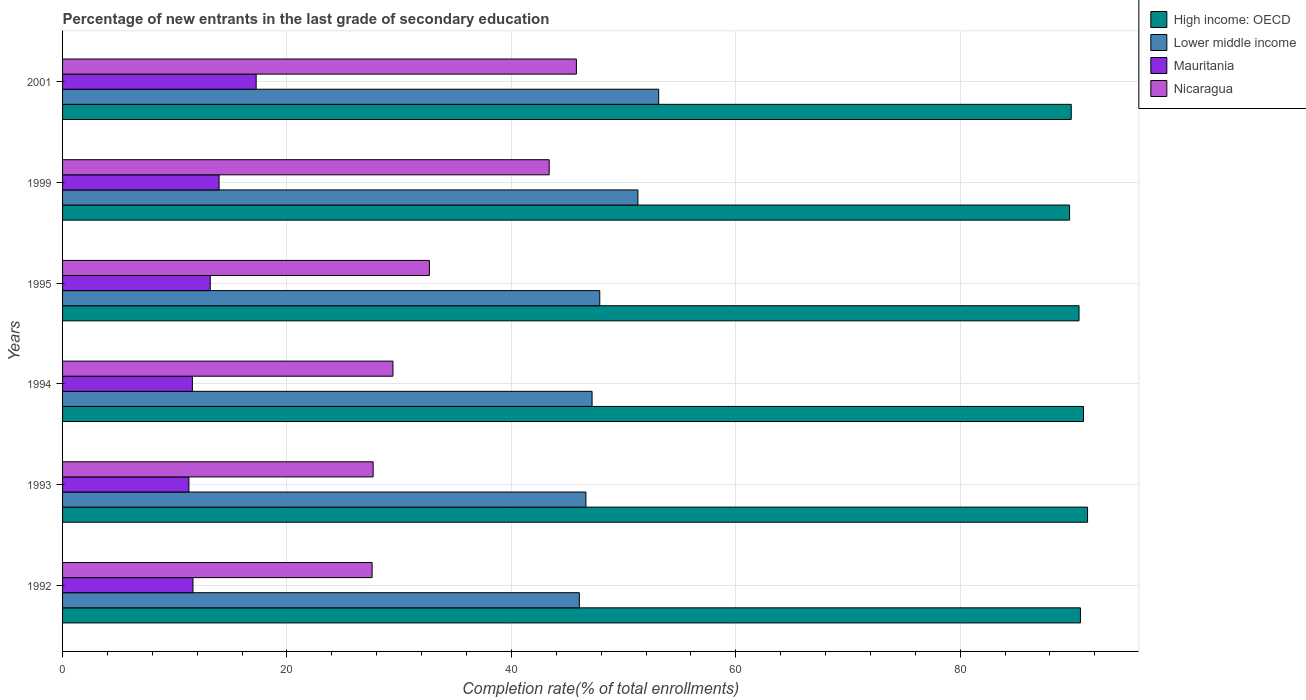How many different coloured bars are there?
Make the answer very short. 4. Are the number of bars per tick equal to the number of legend labels?
Make the answer very short. Yes. What is the label of the 2nd group of bars from the top?
Ensure brevity in your answer.  1999. In how many cases, is the number of bars for a given year not equal to the number of legend labels?
Provide a short and direct response. 0. What is the percentage of new entrants in Lower middle income in 1994?
Make the answer very short. 47.19. Across all years, what is the maximum percentage of new entrants in Mauritania?
Keep it short and to the point. 17.25. Across all years, what is the minimum percentage of new entrants in Nicaragua?
Ensure brevity in your answer.  27.59. In which year was the percentage of new entrants in Mauritania maximum?
Keep it short and to the point. 2001. What is the total percentage of new entrants in Nicaragua in the graph?
Give a very brief answer. 206.58. What is the difference between the percentage of new entrants in Mauritania in 1993 and that in 2001?
Offer a terse response. -5.99. What is the difference between the percentage of new entrants in Mauritania in 1993 and the percentage of new entrants in Lower middle income in 1995?
Your response must be concise. -36.62. What is the average percentage of new entrants in Lower middle income per year?
Keep it short and to the point. 48.7. In the year 2001, what is the difference between the percentage of new entrants in Lower middle income and percentage of new entrants in High income: OECD?
Provide a short and direct response. -36.77. In how many years, is the percentage of new entrants in Mauritania greater than 44 %?
Your answer should be compact. 0. What is the ratio of the percentage of new entrants in Nicaragua in 1992 to that in 2001?
Provide a succinct answer. 0.6. Is the percentage of new entrants in High income: OECD in 1992 less than that in 1995?
Your answer should be compact. No. Is the difference between the percentage of new entrants in Lower middle income in 1992 and 1995 greater than the difference between the percentage of new entrants in High income: OECD in 1992 and 1995?
Your response must be concise. No. What is the difference between the highest and the second highest percentage of new entrants in Nicaragua?
Provide a succinct answer. 2.42. What is the difference between the highest and the lowest percentage of new entrants in Nicaragua?
Offer a very short reply. 18.21. Is the sum of the percentage of new entrants in High income: OECD in 1995 and 2001 greater than the maximum percentage of new entrants in Lower middle income across all years?
Give a very brief answer. Yes. What does the 4th bar from the top in 1993 represents?
Your answer should be compact. High income: OECD. What does the 4th bar from the bottom in 1993 represents?
Your answer should be very brief. Nicaragua. Is it the case that in every year, the sum of the percentage of new entrants in High income: OECD and percentage of new entrants in Lower middle income is greater than the percentage of new entrants in Nicaragua?
Provide a short and direct response. Yes. What is the difference between two consecutive major ticks on the X-axis?
Offer a terse response. 20. Does the graph contain any zero values?
Give a very brief answer. No. How are the legend labels stacked?
Offer a very short reply. Vertical. What is the title of the graph?
Make the answer very short. Percentage of new entrants in the last grade of secondary education. Does "Macedonia" appear as one of the legend labels in the graph?
Offer a very short reply. No. What is the label or title of the X-axis?
Your response must be concise. Completion rate(% of total enrollments). What is the Completion rate(% of total enrollments) of High income: OECD in 1992?
Offer a very short reply. 90.72. What is the Completion rate(% of total enrollments) of Lower middle income in 1992?
Give a very brief answer. 46.06. What is the Completion rate(% of total enrollments) in Mauritania in 1992?
Give a very brief answer. 11.62. What is the Completion rate(% of total enrollments) in Nicaragua in 1992?
Ensure brevity in your answer.  27.59. What is the Completion rate(% of total enrollments) of High income: OECD in 1993?
Ensure brevity in your answer.  91.36. What is the Completion rate(% of total enrollments) of Lower middle income in 1993?
Offer a very short reply. 46.64. What is the Completion rate(% of total enrollments) of Mauritania in 1993?
Ensure brevity in your answer.  11.26. What is the Completion rate(% of total enrollments) in Nicaragua in 1993?
Your answer should be very brief. 27.68. What is the Completion rate(% of total enrollments) of High income: OECD in 1994?
Your response must be concise. 90.99. What is the Completion rate(% of total enrollments) in Lower middle income in 1994?
Provide a succinct answer. 47.19. What is the Completion rate(% of total enrollments) in Mauritania in 1994?
Offer a terse response. 11.57. What is the Completion rate(% of total enrollments) of Nicaragua in 1994?
Offer a terse response. 29.45. What is the Completion rate(% of total enrollments) of High income: OECD in 1995?
Your answer should be compact. 90.6. What is the Completion rate(% of total enrollments) of Lower middle income in 1995?
Your answer should be very brief. 47.88. What is the Completion rate(% of total enrollments) of Mauritania in 1995?
Give a very brief answer. 13.16. What is the Completion rate(% of total enrollments) of Nicaragua in 1995?
Keep it short and to the point. 32.7. What is the Completion rate(% of total enrollments) in High income: OECD in 1999?
Provide a short and direct response. 89.75. What is the Completion rate(% of total enrollments) of Lower middle income in 1999?
Provide a succinct answer. 51.28. What is the Completion rate(% of total enrollments) of Mauritania in 1999?
Your response must be concise. 13.95. What is the Completion rate(% of total enrollments) of Nicaragua in 1999?
Your answer should be very brief. 43.37. What is the Completion rate(% of total enrollments) of High income: OECD in 2001?
Make the answer very short. 89.9. What is the Completion rate(% of total enrollments) of Lower middle income in 2001?
Provide a short and direct response. 53.13. What is the Completion rate(% of total enrollments) in Mauritania in 2001?
Offer a very short reply. 17.25. What is the Completion rate(% of total enrollments) of Nicaragua in 2001?
Your answer should be compact. 45.8. Across all years, what is the maximum Completion rate(% of total enrollments) of High income: OECD?
Provide a short and direct response. 91.36. Across all years, what is the maximum Completion rate(% of total enrollments) of Lower middle income?
Keep it short and to the point. 53.13. Across all years, what is the maximum Completion rate(% of total enrollments) of Mauritania?
Ensure brevity in your answer.  17.25. Across all years, what is the maximum Completion rate(% of total enrollments) in Nicaragua?
Keep it short and to the point. 45.8. Across all years, what is the minimum Completion rate(% of total enrollments) of High income: OECD?
Give a very brief answer. 89.75. Across all years, what is the minimum Completion rate(% of total enrollments) in Lower middle income?
Keep it short and to the point. 46.06. Across all years, what is the minimum Completion rate(% of total enrollments) in Mauritania?
Your response must be concise. 11.26. Across all years, what is the minimum Completion rate(% of total enrollments) of Nicaragua?
Make the answer very short. 27.59. What is the total Completion rate(% of total enrollments) in High income: OECD in the graph?
Make the answer very short. 543.32. What is the total Completion rate(% of total enrollments) in Lower middle income in the graph?
Give a very brief answer. 292.19. What is the total Completion rate(% of total enrollments) of Mauritania in the graph?
Ensure brevity in your answer.  78.82. What is the total Completion rate(% of total enrollments) of Nicaragua in the graph?
Offer a very short reply. 206.58. What is the difference between the Completion rate(% of total enrollments) in High income: OECD in 1992 and that in 1993?
Make the answer very short. -0.64. What is the difference between the Completion rate(% of total enrollments) of Lower middle income in 1992 and that in 1993?
Your answer should be very brief. -0.58. What is the difference between the Completion rate(% of total enrollments) of Mauritania in 1992 and that in 1993?
Provide a succinct answer. 0.36. What is the difference between the Completion rate(% of total enrollments) of Nicaragua in 1992 and that in 1993?
Give a very brief answer. -0.09. What is the difference between the Completion rate(% of total enrollments) of High income: OECD in 1992 and that in 1994?
Keep it short and to the point. -0.27. What is the difference between the Completion rate(% of total enrollments) in Lower middle income in 1992 and that in 1994?
Your response must be concise. -1.13. What is the difference between the Completion rate(% of total enrollments) of Mauritania in 1992 and that in 1994?
Your response must be concise. 0.05. What is the difference between the Completion rate(% of total enrollments) in Nicaragua in 1992 and that in 1994?
Keep it short and to the point. -1.86. What is the difference between the Completion rate(% of total enrollments) of High income: OECD in 1992 and that in 1995?
Give a very brief answer. 0.12. What is the difference between the Completion rate(% of total enrollments) in Lower middle income in 1992 and that in 1995?
Keep it short and to the point. -1.82. What is the difference between the Completion rate(% of total enrollments) in Mauritania in 1992 and that in 1995?
Provide a succinct answer. -1.54. What is the difference between the Completion rate(% of total enrollments) of Nicaragua in 1992 and that in 1995?
Make the answer very short. -5.11. What is the difference between the Completion rate(% of total enrollments) of High income: OECD in 1992 and that in 1999?
Ensure brevity in your answer.  0.97. What is the difference between the Completion rate(% of total enrollments) of Lower middle income in 1992 and that in 1999?
Provide a succinct answer. -5.22. What is the difference between the Completion rate(% of total enrollments) in Mauritania in 1992 and that in 1999?
Offer a terse response. -2.33. What is the difference between the Completion rate(% of total enrollments) in Nicaragua in 1992 and that in 1999?
Provide a short and direct response. -15.78. What is the difference between the Completion rate(% of total enrollments) in High income: OECD in 1992 and that in 2001?
Your answer should be compact. 0.82. What is the difference between the Completion rate(% of total enrollments) of Lower middle income in 1992 and that in 2001?
Provide a short and direct response. -7.07. What is the difference between the Completion rate(% of total enrollments) in Mauritania in 1992 and that in 2001?
Offer a terse response. -5.63. What is the difference between the Completion rate(% of total enrollments) of Nicaragua in 1992 and that in 2001?
Ensure brevity in your answer.  -18.21. What is the difference between the Completion rate(% of total enrollments) in High income: OECD in 1993 and that in 1994?
Your answer should be very brief. 0.37. What is the difference between the Completion rate(% of total enrollments) in Lower middle income in 1993 and that in 1994?
Provide a succinct answer. -0.55. What is the difference between the Completion rate(% of total enrollments) in Mauritania in 1993 and that in 1994?
Provide a short and direct response. -0.31. What is the difference between the Completion rate(% of total enrollments) of Nicaragua in 1993 and that in 1994?
Provide a succinct answer. -1.77. What is the difference between the Completion rate(% of total enrollments) in High income: OECD in 1993 and that in 1995?
Your answer should be compact. 0.76. What is the difference between the Completion rate(% of total enrollments) of Lower middle income in 1993 and that in 1995?
Your response must be concise. -1.24. What is the difference between the Completion rate(% of total enrollments) in Mauritania in 1993 and that in 1995?
Give a very brief answer. -1.9. What is the difference between the Completion rate(% of total enrollments) of Nicaragua in 1993 and that in 1995?
Provide a short and direct response. -5.01. What is the difference between the Completion rate(% of total enrollments) in High income: OECD in 1993 and that in 1999?
Offer a very short reply. 1.6. What is the difference between the Completion rate(% of total enrollments) in Lower middle income in 1993 and that in 1999?
Your response must be concise. -4.64. What is the difference between the Completion rate(% of total enrollments) of Mauritania in 1993 and that in 1999?
Your answer should be compact. -2.69. What is the difference between the Completion rate(% of total enrollments) of Nicaragua in 1993 and that in 1999?
Your answer should be compact. -15.69. What is the difference between the Completion rate(% of total enrollments) in High income: OECD in 1993 and that in 2001?
Your answer should be very brief. 1.45. What is the difference between the Completion rate(% of total enrollments) of Lower middle income in 1993 and that in 2001?
Your answer should be compact. -6.49. What is the difference between the Completion rate(% of total enrollments) in Mauritania in 1993 and that in 2001?
Offer a very short reply. -5.99. What is the difference between the Completion rate(% of total enrollments) in Nicaragua in 1993 and that in 2001?
Your response must be concise. -18.12. What is the difference between the Completion rate(% of total enrollments) of High income: OECD in 1994 and that in 1995?
Your answer should be very brief. 0.4. What is the difference between the Completion rate(% of total enrollments) of Lower middle income in 1994 and that in 1995?
Offer a very short reply. -0.69. What is the difference between the Completion rate(% of total enrollments) in Mauritania in 1994 and that in 1995?
Make the answer very short. -1.59. What is the difference between the Completion rate(% of total enrollments) in Nicaragua in 1994 and that in 1995?
Provide a short and direct response. -3.25. What is the difference between the Completion rate(% of total enrollments) in High income: OECD in 1994 and that in 1999?
Provide a short and direct response. 1.24. What is the difference between the Completion rate(% of total enrollments) of Lower middle income in 1994 and that in 1999?
Offer a very short reply. -4.09. What is the difference between the Completion rate(% of total enrollments) in Mauritania in 1994 and that in 1999?
Ensure brevity in your answer.  -2.38. What is the difference between the Completion rate(% of total enrollments) in Nicaragua in 1994 and that in 1999?
Offer a very short reply. -13.93. What is the difference between the Completion rate(% of total enrollments) of High income: OECD in 1994 and that in 2001?
Give a very brief answer. 1.09. What is the difference between the Completion rate(% of total enrollments) in Lower middle income in 1994 and that in 2001?
Your answer should be compact. -5.94. What is the difference between the Completion rate(% of total enrollments) of Mauritania in 1994 and that in 2001?
Give a very brief answer. -5.68. What is the difference between the Completion rate(% of total enrollments) of Nicaragua in 1994 and that in 2001?
Provide a succinct answer. -16.35. What is the difference between the Completion rate(% of total enrollments) of High income: OECD in 1995 and that in 1999?
Give a very brief answer. 0.84. What is the difference between the Completion rate(% of total enrollments) in Lower middle income in 1995 and that in 1999?
Give a very brief answer. -3.4. What is the difference between the Completion rate(% of total enrollments) in Mauritania in 1995 and that in 1999?
Give a very brief answer. -0.79. What is the difference between the Completion rate(% of total enrollments) in Nicaragua in 1995 and that in 1999?
Your response must be concise. -10.68. What is the difference between the Completion rate(% of total enrollments) in High income: OECD in 1995 and that in 2001?
Keep it short and to the point. 0.69. What is the difference between the Completion rate(% of total enrollments) in Lower middle income in 1995 and that in 2001?
Your response must be concise. -5.25. What is the difference between the Completion rate(% of total enrollments) of Mauritania in 1995 and that in 2001?
Your response must be concise. -4.09. What is the difference between the Completion rate(% of total enrollments) of Nicaragua in 1995 and that in 2001?
Give a very brief answer. -13.1. What is the difference between the Completion rate(% of total enrollments) of High income: OECD in 1999 and that in 2001?
Provide a succinct answer. -0.15. What is the difference between the Completion rate(% of total enrollments) in Lower middle income in 1999 and that in 2001?
Your answer should be compact. -1.85. What is the difference between the Completion rate(% of total enrollments) of Mauritania in 1999 and that in 2001?
Your answer should be very brief. -3.3. What is the difference between the Completion rate(% of total enrollments) in Nicaragua in 1999 and that in 2001?
Provide a short and direct response. -2.42. What is the difference between the Completion rate(% of total enrollments) of High income: OECD in 1992 and the Completion rate(% of total enrollments) of Lower middle income in 1993?
Provide a succinct answer. 44.08. What is the difference between the Completion rate(% of total enrollments) of High income: OECD in 1992 and the Completion rate(% of total enrollments) of Mauritania in 1993?
Give a very brief answer. 79.46. What is the difference between the Completion rate(% of total enrollments) of High income: OECD in 1992 and the Completion rate(% of total enrollments) of Nicaragua in 1993?
Your answer should be compact. 63.04. What is the difference between the Completion rate(% of total enrollments) of Lower middle income in 1992 and the Completion rate(% of total enrollments) of Mauritania in 1993?
Provide a short and direct response. 34.8. What is the difference between the Completion rate(% of total enrollments) in Lower middle income in 1992 and the Completion rate(% of total enrollments) in Nicaragua in 1993?
Keep it short and to the point. 18.38. What is the difference between the Completion rate(% of total enrollments) of Mauritania in 1992 and the Completion rate(% of total enrollments) of Nicaragua in 1993?
Give a very brief answer. -16.06. What is the difference between the Completion rate(% of total enrollments) in High income: OECD in 1992 and the Completion rate(% of total enrollments) in Lower middle income in 1994?
Keep it short and to the point. 43.53. What is the difference between the Completion rate(% of total enrollments) of High income: OECD in 1992 and the Completion rate(% of total enrollments) of Mauritania in 1994?
Your answer should be compact. 79.15. What is the difference between the Completion rate(% of total enrollments) of High income: OECD in 1992 and the Completion rate(% of total enrollments) of Nicaragua in 1994?
Provide a short and direct response. 61.27. What is the difference between the Completion rate(% of total enrollments) of Lower middle income in 1992 and the Completion rate(% of total enrollments) of Mauritania in 1994?
Your answer should be very brief. 34.49. What is the difference between the Completion rate(% of total enrollments) of Lower middle income in 1992 and the Completion rate(% of total enrollments) of Nicaragua in 1994?
Offer a terse response. 16.61. What is the difference between the Completion rate(% of total enrollments) in Mauritania in 1992 and the Completion rate(% of total enrollments) in Nicaragua in 1994?
Provide a succinct answer. -17.82. What is the difference between the Completion rate(% of total enrollments) in High income: OECD in 1992 and the Completion rate(% of total enrollments) in Lower middle income in 1995?
Offer a very short reply. 42.84. What is the difference between the Completion rate(% of total enrollments) of High income: OECD in 1992 and the Completion rate(% of total enrollments) of Mauritania in 1995?
Your answer should be compact. 77.56. What is the difference between the Completion rate(% of total enrollments) of High income: OECD in 1992 and the Completion rate(% of total enrollments) of Nicaragua in 1995?
Provide a short and direct response. 58.03. What is the difference between the Completion rate(% of total enrollments) of Lower middle income in 1992 and the Completion rate(% of total enrollments) of Mauritania in 1995?
Give a very brief answer. 32.9. What is the difference between the Completion rate(% of total enrollments) in Lower middle income in 1992 and the Completion rate(% of total enrollments) in Nicaragua in 1995?
Keep it short and to the point. 13.37. What is the difference between the Completion rate(% of total enrollments) in Mauritania in 1992 and the Completion rate(% of total enrollments) in Nicaragua in 1995?
Offer a terse response. -21.07. What is the difference between the Completion rate(% of total enrollments) in High income: OECD in 1992 and the Completion rate(% of total enrollments) in Lower middle income in 1999?
Ensure brevity in your answer.  39.44. What is the difference between the Completion rate(% of total enrollments) in High income: OECD in 1992 and the Completion rate(% of total enrollments) in Mauritania in 1999?
Provide a succinct answer. 76.77. What is the difference between the Completion rate(% of total enrollments) in High income: OECD in 1992 and the Completion rate(% of total enrollments) in Nicaragua in 1999?
Provide a succinct answer. 47.35. What is the difference between the Completion rate(% of total enrollments) of Lower middle income in 1992 and the Completion rate(% of total enrollments) of Mauritania in 1999?
Provide a succinct answer. 32.11. What is the difference between the Completion rate(% of total enrollments) of Lower middle income in 1992 and the Completion rate(% of total enrollments) of Nicaragua in 1999?
Ensure brevity in your answer.  2.69. What is the difference between the Completion rate(% of total enrollments) of Mauritania in 1992 and the Completion rate(% of total enrollments) of Nicaragua in 1999?
Give a very brief answer. -31.75. What is the difference between the Completion rate(% of total enrollments) of High income: OECD in 1992 and the Completion rate(% of total enrollments) of Lower middle income in 2001?
Your answer should be compact. 37.59. What is the difference between the Completion rate(% of total enrollments) of High income: OECD in 1992 and the Completion rate(% of total enrollments) of Mauritania in 2001?
Keep it short and to the point. 73.47. What is the difference between the Completion rate(% of total enrollments) in High income: OECD in 1992 and the Completion rate(% of total enrollments) in Nicaragua in 2001?
Offer a terse response. 44.92. What is the difference between the Completion rate(% of total enrollments) of Lower middle income in 1992 and the Completion rate(% of total enrollments) of Mauritania in 2001?
Your answer should be compact. 28.81. What is the difference between the Completion rate(% of total enrollments) of Lower middle income in 1992 and the Completion rate(% of total enrollments) of Nicaragua in 2001?
Provide a succinct answer. 0.26. What is the difference between the Completion rate(% of total enrollments) of Mauritania in 1992 and the Completion rate(% of total enrollments) of Nicaragua in 2001?
Your answer should be compact. -34.17. What is the difference between the Completion rate(% of total enrollments) of High income: OECD in 1993 and the Completion rate(% of total enrollments) of Lower middle income in 1994?
Give a very brief answer. 44.16. What is the difference between the Completion rate(% of total enrollments) in High income: OECD in 1993 and the Completion rate(% of total enrollments) in Mauritania in 1994?
Provide a succinct answer. 79.79. What is the difference between the Completion rate(% of total enrollments) of High income: OECD in 1993 and the Completion rate(% of total enrollments) of Nicaragua in 1994?
Your answer should be compact. 61.91. What is the difference between the Completion rate(% of total enrollments) in Lower middle income in 1993 and the Completion rate(% of total enrollments) in Mauritania in 1994?
Provide a short and direct response. 35.07. What is the difference between the Completion rate(% of total enrollments) in Lower middle income in 1993 and the Completion rate(% of total enrollments) in Nicaragua in 1994?
Give a very brief answer. 17.2. What is the difference between the Completion rate(% of total enrollments) in Mauritania in 1993 and the Completion rate(% of total enrollments) in Nicaragua in 1994?
Ensure brevity in your answer.  -18.19. What is the difference between the Completion rate(% of total enrollments) in High income: OECD in 1993 and the Completion rate(% of total enrollments) in Lower middle income in 1995?
Offer a very short reply. 43.48. What is the difference between the Completion rate(% of total enrollments) of High income: OECD in 1993 and the Completion rate(% of total enrollments) of Mauritania in 1995?
Keep it short and to the point. 78.19. What is the difference between the Completion rate(% of total enrollments) of High income: OECD in 1993 and the Completion rate(% of total enrollments) of Nicaragua in 1995?
Your answer should be compact. 58.66. What is the difference between the Completion rate(% of total enrollments) in Lower middle income in 1993 and the Completion rate(% of total enrollments) in Mauritania in 1995?
Ensure brevity in your answer.  33.48. What is the difference between the Completion rate(% of total enrollments) of Lower middle income in 1993 and the Completion rate(% of total enrollments) of Nicaragua in 1995?
Keep it short and to the point. 13.95. What is the difference between the Completion rate(% of total enrollments) of Mauritania in 1993 and the Completion rate(% of total enrollments) of Nicaragua in 1995?
Offer a terse response. -21.43. What is the difference between the Completion rate(% of total enrollments) in High income: OECD in 1993 and the Completion rate(% of total enrollments) in Lower middle income in 1999?
Your answer should be compact. 40.08. What is the difference between the Completion rate(% of total enrollments) in High income: OECD in 1993 and the Completion rate(% of total enrollments) in Mauritania in 1999?
Your response must be concise. 77.41. What is the difference between the Completion rate(% of total enrollments) of High income: OECD in 1993 and the Completion rate(% of total enrollments) of Nicaragua in 1999?
Make the answer very short. 47.98. What is the difference between the Completion rate(% of total enrollments) of Lower middle income in 1993 and the Completion rate(% of total enrollments) of Mauritania in 1999?
Make the answer very short. 32.69. What is the difference between the Completion rate(% of total enrollments) of Lower middle income in 1993 and the Completion rate(% of total enrollments) of Nicaragua in 1999?
Offer a terse response. 3.27. What is the difference between the Completion rate(% of total enrollments) in Mauritania in 1993 and the Completion rate(% of total enrollments) in Nicaragua in 1999?
Your answer should be compact. -32.11. What is the difference between the Completion rate(% of total enrollments) in High income: OECD in 1993 and the Completion rate(% of total enrollments) in Lower middle income in 2001?
Offer a very short reply. 38.23. What is the difference between the Completion rate(% of total enrollments) in High income: OECD in 1993 and the Completion rate(% of total enrollments) in Mauritania in 2001?
Provide a short and direct response. 74.1. What is the difference between the Completion rate(% of total enrollments) of High income: OECD in 1993 and the Completion rate(% of total enrollments) of Nicaragua in 2001?
Your answer should be compact. 45.56. What is the difference between the Completion rate(% of total enrollments) of Lower middle income in 1993 and the Completion rate(% of total enrollments) of Mauritania in 2001?
Your answer should be very brief. 29.39. What is the difference between the Completion rate(% of total enrollments) of Lower middle income in 1993 and the Completion rate(% of total enrollments) of Nicaragua in 2001?
Your response must be concise. 0.85. What is the difference between the Completion rate(% of total enrollments) of Mauritania in 1993 and the Completion rate(% of total enrollments) of Nicaragua in 2001?
Offer a terse response. -34.54. What is the difference between the Completion rate(% of total enrollments) of High income: OECD in 1994 and the Completion rate(% of total enrollments) of Lower middle income in 1995?
Keep it short and to the point. 43.11. What is the difference between the Completion rate(% of total enrollments) of High income: OECD in 1994 and the Completion rate(% of total enrollments) of Mauritania in 1995?
Your answer should be very brief. 77.83. What is the difference between the Completion rate(% of total enrollments) in High income: OECD in 1994 and the Completion rate(% of total enrollments) in Nicaragua in 1995?
Provide a short and direct response. 58.3. What is the difference between the Completion rate(% of total enrollments) of Lower middle income in 1994 and the Completion rate(% of total enrollments) of Mauritania in 1995?
Ensure brevity in your answer.  34.03. What is the difference between the Completion rate(% of total enrollments) of Lower middle income in 1994 and the Completion rate(% of total enrollments) of Nicaragua in 1995?
Provide a succinct answer. 14.5. What is the difference between the Completion rate(% of total enrollments) of Mauritania in 1994 and the Completion rate(% of total enrollments) of Nicaragua in 1995?
Your response must be concise. -21.13. What is the difference between the Completion rate(% of total enrollments) of High income: OECD in 1994 and the Completion rate(% of total enrollments) of Lower middle income in 1999?
Offer a terse response. 39.71. What is the difference between the Completion rate(% of total enrollments) in High income: OECD in 1994 and the Completion rate(% of total enrollments) in Mauritania in 1999?
Keep it short and to the point. 77.04. What is the difference between the Completion rate(% of total enrollments) of High income: OECD in 1994 and the Completion rate(% of total enrollments) of Nicaragua in 1999?
Offer a terse response. 47.62. What is the difference between the Completion rate(% of total enrollments) in Lower middle income in 1994 and the Completion rate(% of total enrollments) in Mauritania in 1999?
Ensure brevity in your answer.  33.24. What is the difference between the Completion rate(% of total enrollments) of Lower middle income in 1994 and the Completion rate(% of total enrollments) of Nicaragua in 1999?
Your answer should be compact. 3.82. What is the difference between the Completion rate(% of total enrollments) of Mauritania in 1994 and the Completion rate(% of total enrollments) of Nicaragua in 1999?
Keep it short and to the point. -31.8. What is the difference between the Completion rate(% of total enrollments) of High income: OECD in 1994 and the Completion rate(% of total enrollments) of Lower middle income in 2001?
Your response must be concise. 37.86. What is the difference between the Completion rate(% of total enrollments) in High income: OECD in 1994 and the Completion rate(% of total enrollments) in Mauritania in 2001?
Your response must be concise. 73.74. What is the difference between the Completion rate(% of total enrollments) in High income: OECD in 1994 and the Completion rate(% of total enrollments) in Nicaragua in 2001?
Your response must be concise. 45.19. What is the difference between the Completion rate(% of total enrollments) in Lower middle income in 1994 and the Completion rate(% of total enrollments) in Mauritania in 2001?
Offer a terse response. 29.94. What is the difference between the Completion rate(% of total enrollments) in Lower middle income in 1994 and the Completion rate(% of total enrollments) in Nicaragua in 2001?
Ensure brevity in your answer.  1.4. What is the difference between the Completion rate(% of total enrollments) of Mauritania in 1994 and the Completion rate(% of total enrollments) of Nicaragua in 2001?
Offer a very short reply. -34.23. What is the difference between the Completion rate(% of total enrollments) of High income: OECD in 1995 and the Completion rate(% of total enrollments) of Lower middle income in 1999?
Provide a succinct answer. 39.32. What is the difference between the Completion rate(% of total enrollments) of High income: OECD in 1995 and the Completion rate(% of total enrollments) of Mauritania in 1999?
Your response must be concise. 76.65. What is the difference between the Completion rate(% of total enrollments) of High income: OECD in 1995 and the Completion rate(% of total enrollments) of Nicaragua in 1999?
Offer a very short reply. 47.22. What is the difference between the Completion rate(% of total enrollments) of Lower middle income in 1995 and the Completion rate(% of total enrollments) of Mauritania in 1999?
Ensure brevity in your answer.  33.93. What is the difference between the Completion rate(% of total enrollments) in Lower middle income in 1995 and the Completion rate(% of total enrollments) in Nicaragua in 1999?
Offer a terse response. 4.51. What is the difference between the Completion rate(% of total enrollments) in Mauritania in 1995 and the Completion rate(% of total enrollments) in Nicaragua in 1999?
Your response must be concise. -30.21. What is the difference between the Completion rate(% of total enrollments) of High income: OECD in 1995 and the Completion rate(% of total enrollments) of Lower middle income in 2001?
Keep it short and to the point. 37.46. What is the difference between the Completion rate(% of total enrollments) in High income: OECD in 1995 and the Completion rate(% of total enrollments) in Mauritania in 2001?
Offer a terse response. 73.34. What is the difference between the Completion rate(% of total enrollments) of High income: OECD in 1995 and the Completion rate(% of total enrollments) of Nicaragua in 2001?
Provide a succinct answer. 44.8. What is the difference between the Completion rate(% of total enrollments) of Lower middle income in 1995 and the Completion rate(% of total enrollments) of Mauritania in 2001?
Provide a short and direct response. 30.63. What is the difference between the Completion rate(% of total enrollments) in Lower middle income in 1995 and the Completion rate(% of total enrollments) in Nicaragua in 2001?
Ensure brevity in your answer.  2.08. What is the difference between the Completion rate(% of total enrollments) in Mauritania in 1995 and the Completion rate(% of total enrollments) in Nicaragua in 2001?
Your answer should be very brief. -32.63. What is the difference between the Completion rate(% of total enrollments) in High income: OECD in 1999 and the Completion rate(% of total enrollments) in Lower middle income in 2001?
Make the answer very short. 36.62. What is the difference between the Completion rate(% of total enrollments) in High income: OECD in 1999 and the Completion rate(% of total enrollments) in Mauritania in 2001?
Offer a very short reply. 72.5. What is the difference between the Completion rate(% of total enrollments) of High income: OECD in 1999 and the Completion rate(% of total enrollments) of Nicaragua in 2001?
Give a very brief answer. 43.96. What is the difference between the Completion rate(% of total enrollments) in Lower middle income in 1999 and the Completion rate(% of total enrollments) in Mauritania in 2001?
Provide a short and direct response. 34.03. What is the difference between the Completion rate(% of total enrollments) in Lower middle income in 1999 and the Completion rate(% of total enrollments) in Nicaragua in 2001?
Provide a short and direct response. 5.48. What is the difference between the Completion rate(% of total enrollments) of Mauritania in 1999 and the Completion rate(% of total enrollments) of Nicaragua in 2001?
Offer a terse response. -31.85. What is the average Completion rate(% of total enrollments) of High income: OECD per year?
Provide a short and direct response. 90.55. What is the average Completion rate(% of total enrollments) in Lower middle income per year?
Give a very brief answer. 48.7. What is the average Completion rate(% of total enrollments) in Mauritania per year?
Provide a succinct answer. 13.14. What is the average Completion rate(% of total enrollments) of Nicaragua per year?
Offer a very short reply. 34.43. In the year 1992, what is the difference between the Completion rate(% of total enrollments) of High income: OECD and Completion rate(% of total enrollments) of Lower middle income?
Provide a short and direct response. 44.66. In the year 1992, what is the difference between the Completion rate(% of total enrollments) in High income: OECD and Completion rate(% of total enrollments) in Mauritania?
Ensure brevity in your answer.  79.1. In the year 1992, what is the difference between the Completion rate(% of total enrollments) of High income: OECD and Completion rate(% of total enrollments) of Nicaragua?
Ensure brevity in your answer.  63.13. In the year 1992, what is the difference between the Completion rate(% of total enrollments) in Lower middle income and Completion rate(% of total enrollments) in Mauritania?
Your response must be concise. 34.44. In the year 1992, what is the difference between the Completion rate(% of total enrollments) of Lower middle income and Completion rate(% of total enrollments) of Nicaragua?
Provide a succinct answer. 18.47. In the year 1992, what is the difference between the Completion rate(% of total enrollments) of Mauritania and Completion rate(% of total enrollments) of Nicaragua?
Ensure brevity in your answer.  -15.97. In the year 1993, what is the difference between the Completion rate(% of total enrollments) of High income: OECD and Completion rate(% of total enrollments) of Lower middle income?
Your response must be concise. 44.71. In the year 1993, what is the difference between the Completion rate(% of total enrollments) of High income: OECD and Completion rate(% of total enrollments) of Mauritania?
Ensure brevity in your answer.  80.1. In the year 1993, what is the difference between the Completion rate(% of total enrollments) of High income: OECD and Completion rate(% of total enrollments) of Nicaragua?
Your answer should be very brief. 63.68. In the year 1993, what is the difference between the Completion rate(% of total enrollments) in Lower middle income and Completion rate(% of total enrollments) in Mauritania?
Ensure brevity in your answer.  35.38. In the year 1993, what is the difference between the Completion rate(% of total enrollments) in Lower middle income and Completion rate(% of total enrollments) in Nicaragua?
Provide a succinct answer. 18.96. In the year 1993, what is the difference between the Completion rate(% of total enrollments) in Mauritania and Completion rate(% of total enrollments) in Nicaragua?
Offer a terse response. -16.42. In the year 1994, what is the difference between the Completion rate(% of total enrollments) of High income: OECD and Completion rate(% of total enrollments) of Lower middle income?
Offer a terse response. 43.8. In the year 1994, what is the difference between the Completion rate(% of total enrollments) of High income: OECD and Completion rate(% of total enrollments) of Mauritania?
Make the answer very short. 79.42. In the year 1994, what is the difference between the Completion rate(% of total enrollments) in High income: OECD and Completion rate(% of total enrollments) in Nicaragua?
Ensure brevity in your answer.  61.54. In the year 1994, what is the difference between the Completion rate(% of total enrollments) in Lower middle income and Completion rate(% of total enrollments) in Mauritania?
Offer a terse response. 35.63. In the year 1994, what is the difference between the Completion rate(% of total enrollments) in Lower middle income and Completion rate(% of total enrollments) in Nicaragua?
Your answer should be compact. 17.75. In the year 1994, what is the difference between the Completion rate(% of total enrollments) of Mauritania and Completion rate(% of total enrollments) of Nicaragua?
Your answer should be compact. -17.88. In the year 1995, what is the difference between the Completion rate(% of total enrollments) of High income: OECD and Completion rate(% of total enrollments) of Lower middle income?
Give a very brief answer. 42.72. In the year 1995, what is the difference between the Completion rate(% of total enrollments) of High income: OECD and Completion rate(% of total enrollments) of Mauritania?
Ensure brevity in your answer.  77.43. In the year 1995, what is the difference between the Completion rate(% of total enrollments) in High income: OECD and Completion rate(% of total enrollments) in Nicaragua?
Offer a very short reply. 57.9. In the year 1995, what is the difference between the Completion rate(% of total enrollments) of Lower middle income and Completion rate(% of total enrollments) of Mauritania?
Make the answer very short. 34.72. In the year 1995, what is the difference between the Completion rate(% of total enrollments) in Lower middle income and Completion rate(% of total enrollments) in Nicaragua?
Keep it short and to the point. 15.18. In the year 1995, what is the difference between the Completion rate(% of total enrollments) of Mauritania and Completion rate(% of total enrollments) of Nicaragua?
Give a very brief answer. -19.53. In the year 1999, what is the difference between the Completion rate(% of total enrollments) in High income: OECD and Completion rate(% of total enrollments) in Lower middle income?
Make the answer very short. 38.47. In the year 1999, what is the difference between the Completion rate(% of total enrollments) in High income: OECD and Completion rate(% of total enrollments) in Mauritania?
Your answer should be very brief. 75.8. In the year 1999, what is the difference between the Completion rate(% of total enrollments) in High income: OECD and Completion rate(% of total enrollments) in Nicaragua?
Your response must be concise. 46.38. In the year 1999, what is the difference between the Completion rate(% of total enrollments) in Lower middle income and Completion rate(% of total enrollments) in Mauritania?
Offer a terse response. 37.33. In the year 1999, what is the difference between the Completion rate(% of total enrollments) in Lower middle income and Completion rate(% of total enrollments) in Nicaragua?
Offer a very short reply. 7.91. In the year 1999, what is the difference between the Completion rate(% of total enrollments) in Mauritania and Completion rate(% of total enrollments) in Nicaragua?
Your response must be concise. -29.42. In the year 2001, what is the difference between the Completion rate(% of total enrollments) of High income: OECD and Completion rate(% of total enrollments) of Lower middle income?
Ensure brevity in your answer.  36.77. In the year 2001, what is the difference between the Completion rate(% of total enrollments) of High income: OECD and Completion rate(% of total enrollments) of Mauritania?
Offer a very short reply. 72.65. In the year 2001, what is the difference between the Completion rate(% of total enrollments) of High income: OECD and Completion rate(% of total enrollments) of Nicaragua?
Give a very brief answer. 44.1. In the year 2001, what is the difference between the Completion rate(% of total enrollments) in Lower middle income and Completion rate(% of total enrollments) in Mauritania?
Your response must be concise. 35.88. In the year 2001, what is the difference between the Completion rate(% of total enrollments) of Lower middle income and Completion rate(% of total enrollments) of Nicaragua?
Your answer should be very brief. 7.33. In the year 2001, what is the difference between the Completion rate(% of total enrollments) in Mauritania and Completion rate(% of total enrollments) in Nicaragua?
Ensure brevity in your answer.  -28.54. What is the ratio of the Completion rate(% of total enrollments) in Lower middle income in 1992 to that in 1993?
Provide a succinct answer. 0.99. What is the ratio of the Completion rate(% of total enrollments) of Mauritania in 1992 to that in 1993?
Offer a terse response. 1.03. What is the ratio of the Completion rate(% of total enrollments) of Mauritania in 1992 to that in 1994?
Provide a succinct answer. 1. What is the ratio of the Completion rate(% of total enrollments) in Nicaragua in 1992 to that in 1994?
Make the answer very short. 0.94. What is the ratio of the Completion rate(% of total enrollments) in Lower middle income in 1992 to that in 1995?
Keep it short and to the point. 0.96. What is the ratio of the Completion rate(% of total enrollments) of Mauritania in 1992 to that in 1995?
Your response must be concise. 0.88. What is the ratio of the Completion rate(% of total enrollments) of Nicaragua in 1992 to that in 1995?
Provide a short and direct response. 0.84. What is the ratio of the Completion rate(% of total enrollments) of High income: OECD in 1992 to that in 1999?
Your answer should be compact. 1.01. What is the ratio of the Completion rate(% of total enrollments) in Lower middle income in 1992 to that in 1999?
Provide a short and direct response. 0.9. What is the ratio of the Completion rate(% of total enrollments) of Mauritania in 1992 to that in 1999?
Offer a very short reply. 0.83. What is the ratio of the Completion rate(% of total enrollments) in Nicaragua in 1992 to that in 1999?
Your response must be concise. 0.64. What is the ratio of the Completion rate(% of total enrollments) in High income: OECD in 1992 to that in 2001?
Offer a very short reply. 1.01. What is the ratio of the Completion rate(% of total enrollments) in Lower middle income in 1992 to that in 2001?
Ensure brevity in your answer.  0.87. What is the ratio of the Completion rate(% of total enrollments) in Mauritania in 1992 to that in 2001?
Give a very brief answer. 0.67. What is the ratio of the Completion rate(% of total enrollments) of Nicaragua in 1992 to that in 2001?
Give a very brief answer. 0.6. What is the ratio of the Completion rate(% of total enrollments) of High income: OECD in 1993 to that in 1994?
Your response must be concise. 1. What is the ratio of the Completion rate(% of total enrollments) in Lower middle income in 1993 to that in 1994?
Provide a succinct answer. 0.99. What is the ratio of the Completion rate(% of total enrollments) of Mauritania in 1993 to that in 1994?
Provide a succinct answer. 0.97. What is the ratio of the Completion rate(% of total enrollments) of High income: OECD in 1993 to that in 1995?
Ensure brevity in your answer.  1.01. What is the ratio of the Completion rate(% of total enrollments) of Lower middle income in 1993 to that in 1995?
Give a very brief answer. 0.97. What is the ratio of the Completion rate(% of total enrollments) in Mauritania in 1993 to that in 1995?
Provide a succinct answer. 0.86. What is the ratio of the Completion rate(% of total enrollments) of Nicaragua in 1993 to that in 1995?
Provide a short and direct response. 0.85. What is the ratio of the Completion rate(% of total enrollments) of High income: OECD in 1993 to that in 1999?
Your answer should be very brief. 1.02. What is the ratio of the Completion rate(% of total enrollments) of Lower middle income in 1993 to that in 1999?
Make the answer very short. 0.91. What is the ratio of the Completion rate(% of total enrollments) of Mauritania in 1993 to that in 1999?
Make the answer very short. 0.81. What is the ratio of the Completion rate(% of total enrollments) in Nicaragua in 1993 to that in 1999?
Give a very brief answer. 0.64. What is the ratio of the Completion rate(% of total enrollments) of High income: OECD in 1993 to that in 2001?
Your answer should be compact. 1.02. What is the ratio of the Completion rate(% of total enrollments) in Lower middle income in 1993 to that in 2001?
Offer a very short reply. 0.88. What is the ratio of the Completion rate(% of total enrollments) in Mauritania in 1993 to that in 2001?
Offer a terse response. 0.65. What is the ratio of the Completion rate(% of total enrollments) of Nicaragua in 1993 to that in 2001?
Keep it short and to the point. 0.6. What is the ratio of the Completion rate(% of total enrollments) of High income: OECD in 1994 to that in 1995?
Offer a very short reply. 1. What is the ratio of the Completion rate(% of total enrollments) in Lower middle income in 1994 to that in 1995?
Ensure brevity in your answer.  0.99. What is the ratio of the Completion rate(% of total enrollments) of Mauritania in 1994 to that in 1995?
Provide a succinct answer. 0.88. What is the ratio of the Completion rate(% of total enrollments) of Nicaragua in 1994 to that in 1995?
Make the answer very short. 0.9. What is the ratio of the Completion rate(% of total enrollments) in High income: OECD in 1994 to that in 1999?
Ensure brevity in your answer.  1.01. What is the ratio of the Completion rate(% of total enrollments) in Lower middle income in 1994 to that in 1999?
Ensure brevity in your answer.  0.92. What is the ratio of the Completion rate(% of total enrollments) of Mauritania in 1994 to that in 1999?
Make the answer very short. 0.83. What is the ratio of the Completion rate(% of total enrollments) in Nicaragua in 1994 to that in 1999?
Keep it short and to the point. 0.68. What is the ratio of the Completion rate(% of total enrollments) in High income: OECD in 1994 to that in 2001?
Ensure brevity in your answer.  1.01. What is the ratio of the Completion rate(% of total enrollments) of Lower middle income in 1994 to that in 2001?
Your answer should be compact. 0.89. What is the ratio of the Completion rate(% of total enrollments) in Mauritania in 1994 to that in 2001?
Your answer should be compact. 0.67. What is the ratio of the Completion rate(% of total enrollments) in Nicaragua in 1994 to that in 2001?
Your answer should be very brief. 0.64. What is the ratio of the Completion rate(% of total enrollments) in High income: OECD in 1995 to that in 1999?
Your answer should be compact. 1.01. What is the ratio of the Completion rate(% of total enrollments) of Lower middle income in 1995 to that in 1999?
Offer a very short reply. 0.93. What is the ratio of the Completion rate(% of total enrollments) in Mauritania in 1995 to that in 1999?
Your answer should be very brief. 0.94. What is the ratio of the Completion rate(% of total enrollments) of Nicaragua in 1995 to that in 1999?
Offer a terse response. 0.75. What is the ratio of the Completion rate(% of total enrollments) in High income: OECD in 1995 to that in 2001?
Offer a terse response. 1.01. What is the ratio of the Completion rate(% of total enrollments) in Lower middle income in 1995 to that in 2001?
Your response must be concise. 0.9. What is the ratio of the Completion rate(% of total enrollments) of Mauritania in 1995 to that in 2001?
Keep it short and to the point. 0.76. What is the ratio of the Completion rate(% of total enrollments) of Nicaragua in 1995 to that in 2001?
Ensure brevity in your answer.  0.71. What is the ratio of the Completion rate(% of total enrollments) of High income: OECD in 1999 to that in 2001?
Provide a succinct answer. 1. What is the ratio of the Completion rate(% of total enrollments) of Lower middle income in 1999 to that in 2001?
Provide a succinct answer. 0.97. What is the ratio of the Completion rate(% of total enrollments) in Mauritania in 1999 to that in 2001?
Provide a succinct answer. 0.81. What is the ratio of the Completion rate(% of total enrollments) of Nicaragua in 1999 to that in 2001?
Keep it short and to the point. 0.95. What is the difference between the highest and the second highest Completion rate(% of total enrollments) of High income: OECD?
Provide a short and direct response. 0.37. What is the difference between the highest and the second highest Completion rate(% of total enrollments) of Lower middle income?
Keep it short and to the point. 1.85. What is the difference between the highest and the second highest Completion rate(% of total enrollments) of Mauritania?
Provide a short and direct response. 3.3. What is the difference between the highest and the second highest Completion rate(% of total enrollments) of Nicaragua?
Your response must be concise. 2.42. What is the difference between the highest and the lowest Completion rate(% of total enrollments) in High income: OECD?
Keep it short and to the point. 1.6. What is the difference between the highest and the lowest Completion rate(% of total enrollments) of Lower middle income?
Your answer should be very brief. 7.07. What is the difference between the highest and the lowest Completion rate(% of total enrollments) in Mauritania?
Your response must be concise. 5.99. What is the difference between the highest and the lowest Completion rate(% of total enrollments) of Nicaragua?
Keep it short and to the point. 18.21. 